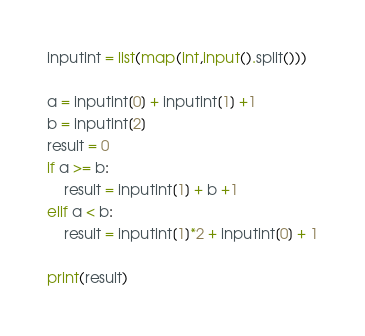<code> <loc_0><loc_0><loc_500><loc_500><_Python_>inputint = list(map(int,input().split()))

a = inputint[0] + inputint[1] +1
b = inputint[2]
result = 0
if a >= b:
    result = inputint[1] + b +1
elif a < b:
    result = inputint[1]*2 + inputint[0] + 1

print(result)</code> 